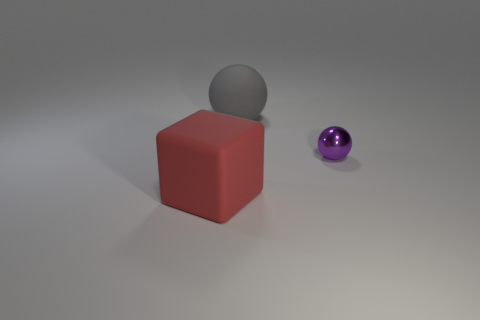Are there any other things that have the same size as the purple object?
Your answer should be very brief. No. How many objects have the same color as the small ball?
Your answer should be very brief. 0. How many things are right of the big red thing and on the left side of the purple metal sphere?
Give a very brief answer. 1. There is a red rubber object that is the same size as the gray ball; what shape is it?
Offer a very short reply. Cube. The rubber sphere has what size?
Your answer should be very brief. Large. The small purple object that is to the right of the matte object to the left of the large matte object behind the big matte block is made of what material?
Offer a very short reply. Metal. The cube that is the same material as the gray object is what color?
Make the answer very short. Red. How many metal balls are left of the thing left of the large thing that is behind the purple shiny object?
Offer a very short reply. 0. Are there any other things that have the same shape as the small purple object?
Offer a terse response. Yes. What number of objects are matte things that are in front of the tiny metal sphere or small blue metallic blocks?
Your response must be concise. 1. 